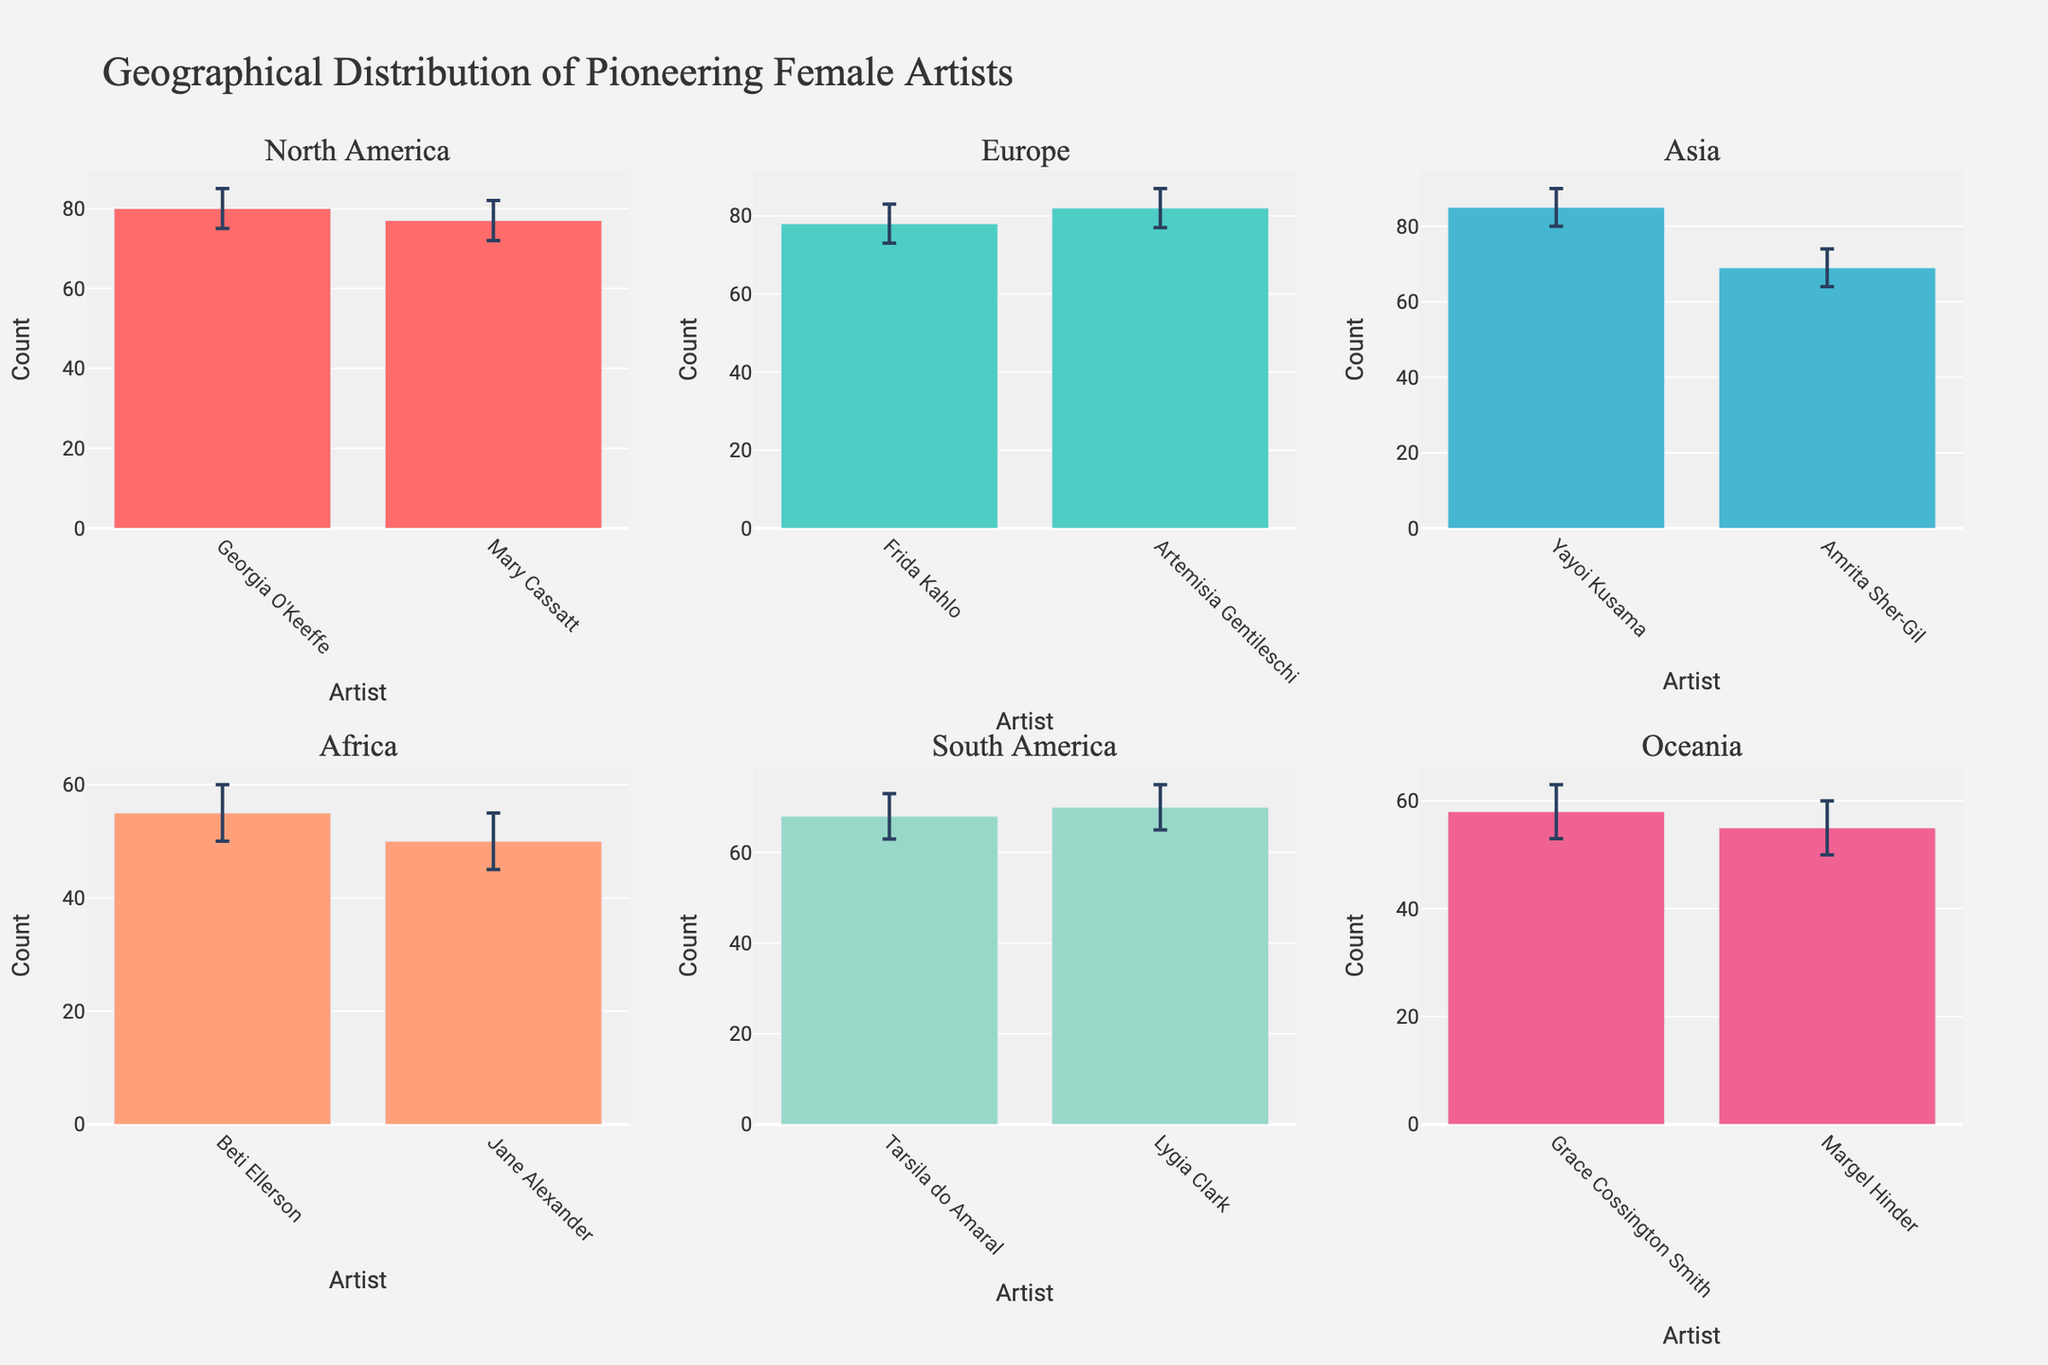What's the title of the plot? The title can be found at the top of the figure. It is usually a summary of what the figure represents.
Answer: Geographical Distribution of Pioneering Female Artists What are the X and Y axes labeled as in the Europe subplot? Each subplot has its own X and Y axes labels, visible below and to the left of the respective subplot. In the Europe subplot, the X axis is labeled "Artist" and the Y axis is labeled "Count."
Answer: Artist, Count Which continent has the highest count of pioneering female artists? By visually inspecting each subplot, we can see the artist with the highest count and identify the continent. Asia has Yayoi Kusama with the highest count of 85.
Answer: Asia What’s the average count of pioneering female artists in Africa? Identify the counts for African artists and calculate the average. The counts are 55 and 50. The sum is 55 + 50 = 105 and the average is 105 / 2 = 52.5.
Answer: 52.5 Which artist has the largest error margin in their historical record correctness in North America? North America's artists are Georgia O'Keeffe and Mary Cassatt. Calculate the error margin for both and compare. Georgia O'Keeffe's margin is 85 - 75 = 10, Mary Cassatt's is 82 - 72 = 10. Both have the same error margin.
Answer: Georgia O'Keeffe and Mary Cassatt How many artists are represented in the Oceania subplot? Count the number of artists indicated by the bars in the Oceania subplot. There are two artists: Grace Cossington Smith and Margel Hinder.
Answer: 2 Compare the counts of pioneering female artists in North America and South America subplots. Which continent has a higher cumulative count? Sum the counts for the artists in North America and South America and compare. North America's counts: 80 + 77 = 157. South America's counts: 68 + 70 = 138. North America has a higher cumulative count.
Answer: North America In the Asia subplot, what is the difference in count between Yayoi Kusama and Amrita Sher-Gil? Identify the counts for both artists in the Asia subplot and calculate the difference. Yayoi Kusama has a count of 85 and Amrita Sher-Gil has a count of 69. The difference is 85 - 69 = 16.
Answer: 16 Which subplot has the artist with the smallest error margin, and who is that artist? Calculate the error margin for each artist and compare them. Amrita Sher-Gil in Asia has the smallest error margin, as the range is 74 - 64 = 10.
Answer: Asia, Amrita Sher-Gil 